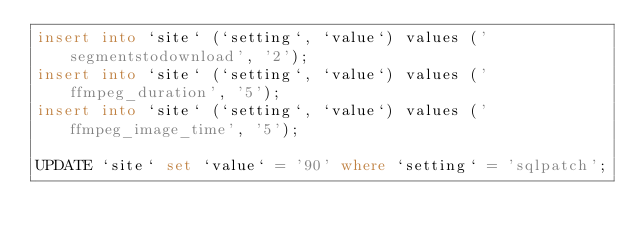<code> <loc_0><loc_0><loc_500><loc_500><_SQL_>insert into `site` (`setting`, `value`) values ('segmentstodownload', '2');
insert into `site` (`setting`, `value`) values ('ffmpeg_duration', '5');
insert into `site` (`setting`, `value`) values ('ffmpeg_image_time', '5');

UPDATE `site` set `value` = '90' where `setting` = 'sqlpatch';
</code> 